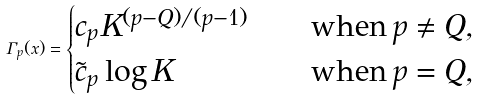Convert formula to latex. <formula><loc_0><loc_0><loc_500><loc_500>\Gamma _ { p } ( x ) = \begin{cases} c _ { p } K ^ { ( p - Q ) / ( p - 1 ) } & \quad \text {when} \, p \ne Q , \\ \tilde { c } _ { p } \log K & \quad \text {when} \, p = Q , \end{cases}</formula> 